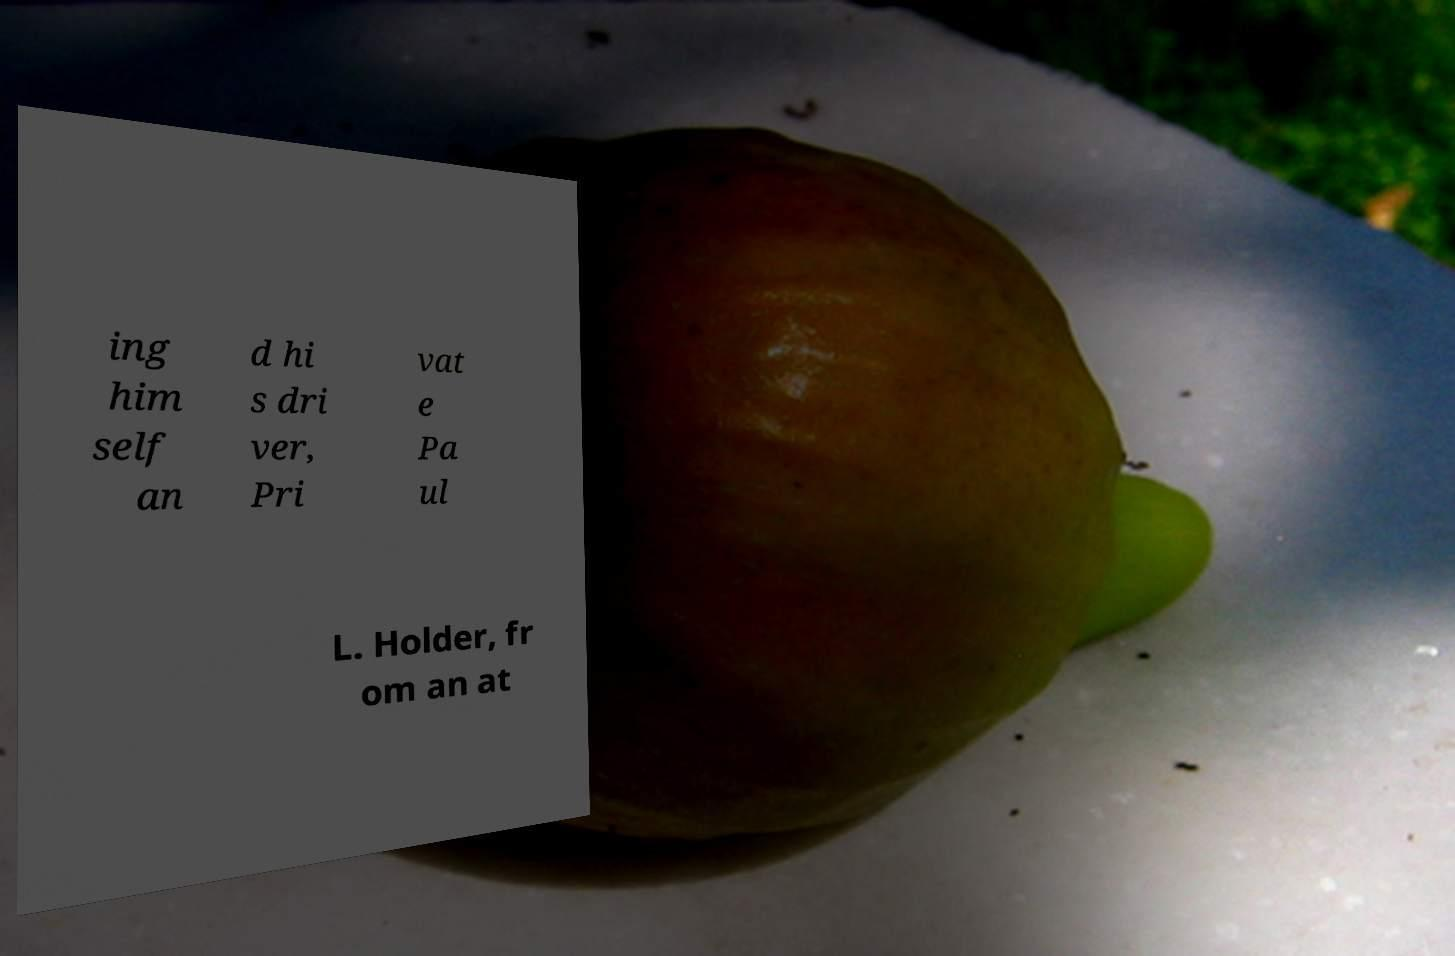I need the written content from this picture converted into text. Can you do that? ing him self an d hi s dri ver, Pri vat e Pa ul L. Holder, fr om an at 